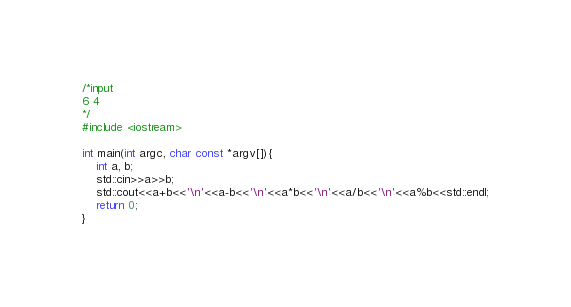<code> <loc_0><loc_0><loc_500><loc_500><_C++_>/*input
6 4
*/
#include <iostream>

int main(int argc, char const *argv[]){
	int a, b;
	std::cin>>a>>b;
	std::cout<<a+b<<'\n'<<a-b<<'\n'<<a*b<<'\n'<<a/b<<'\n'<<a%b<<std::endl;
	return 0;
}</code> 